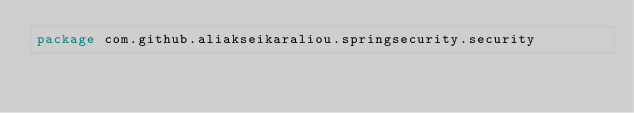Convert code to text. <code><loc_0><loc_0><loc_500><loc_500><_Kotlin_>package com.github.aliakseikaraliou.springsecurity.security
</code> 